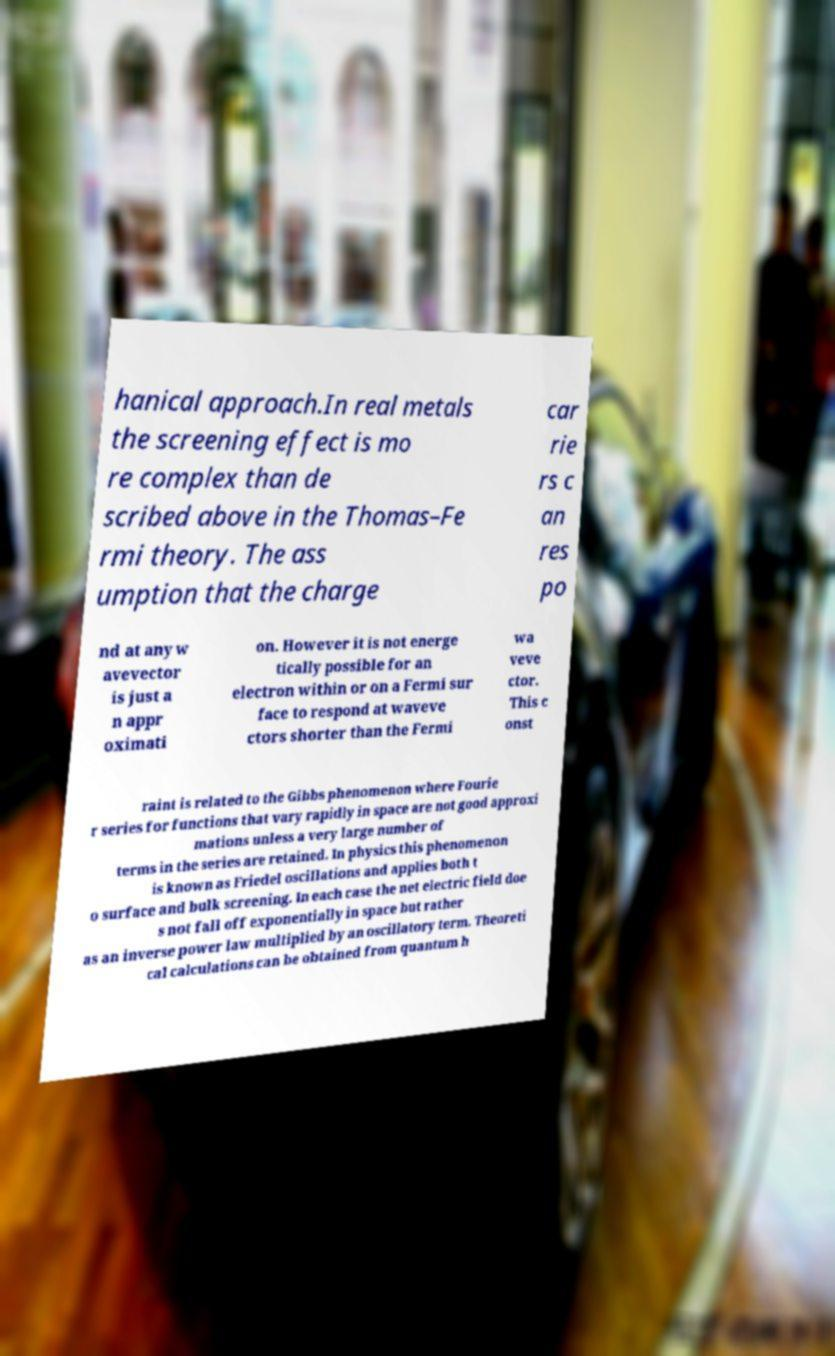Please read and relay the text visible in this image. What does it say? hanical approach.In real metals the screening effect is mo re complex than de scribed above in the Thomas–Fe rmi theory. The ass umption that the charge car rie rs c an res po nd at any w avevector is just a n appr oximati on. However it is not energe tically possible for an electron within or on a Fermi sur face to respond at waveve ctors shorter than the Fermi wa veve ctor. This c onst raint is related to the Gibbs phenomenon where Fourie r series for functions that vary rapidly in space are not good approxi mations unless a very large number of terms in the series are retained. In physics this phenomenon is known as Friedel oscillations and applies both t o surface and bulk screening. In each case the net electric field doe s not fall off exponentially in space but rather as an inverse power law multiplied by an oscillatory term. Theoreti cal calculations can be obtained from quantum h 